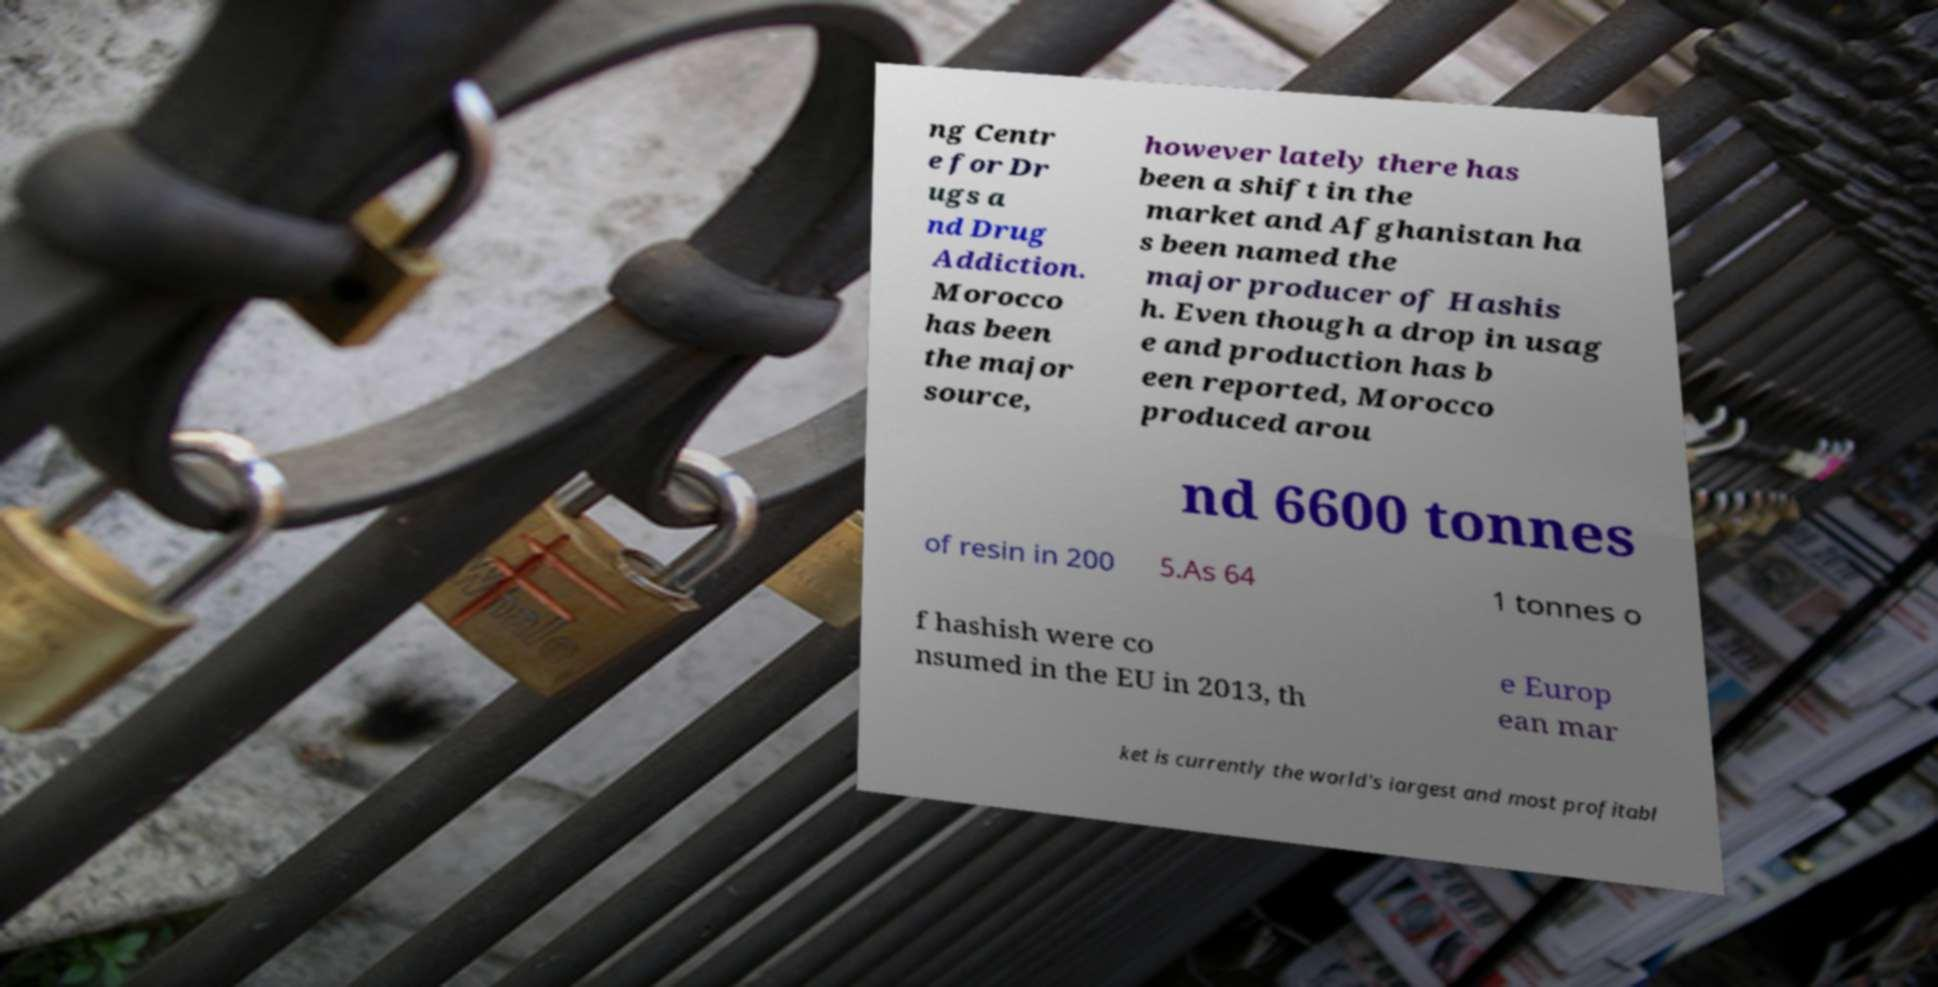Can you accurately transcribe the text from the provided image for me? ng Centr e for Dr ugs a nd Drug Addiction. Morocco has been the major source, however lately there has been a shift in the market and Afghanistan ha s been named the major producer of Hashis h. Even though a drop in usag e and production has b een reported, Morocco produced arou nd 6600 tonnes of resin in 200 5.As 64 1 tonnes o f hashish were co nsumed in the EU in 2013, th e Europ ean mar ket is currently the world's largest and most profitabl 